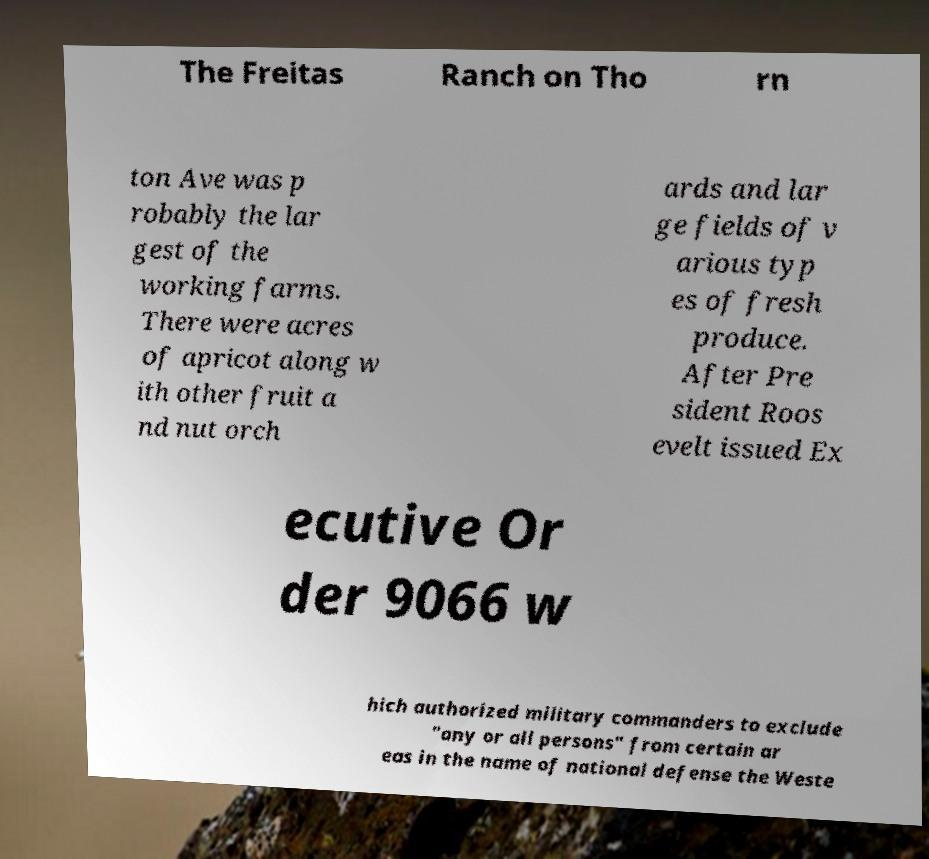For documentation purposes, I need the text within this image transcribed. Could you provide that? The Freitas Ranch on Tho rn ton Ave was p robably the lar gest of the working farms. There were acres of apricot along w ith other fruit a nd nut orch ards and lar ge fields of v arious typ es of fresh produce. After Pre sident Roos evelt issued Ex ecutive Or der 9066 w hich authorized military commanders to exclude "any or all persons" from certain ar eas in the name of national defense the Weste 